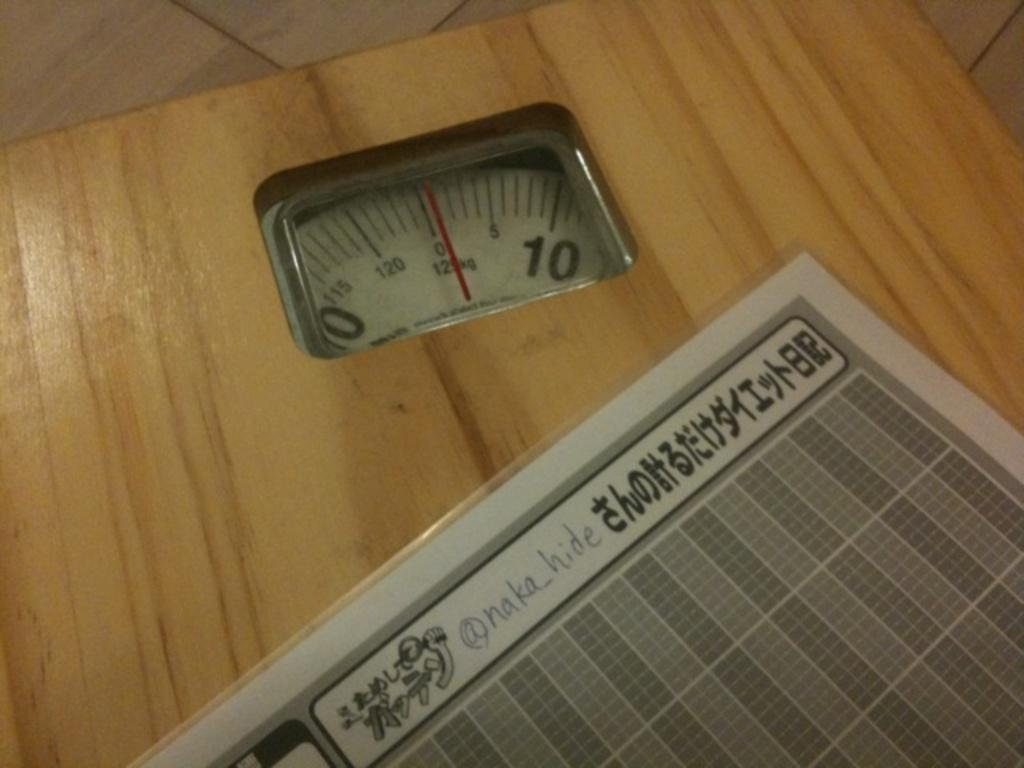What object is present in the image that is used for measuring weight? There is a weighing machine in the image that is used for measuring weight. Where is the weighing machine located in the image? The weighing machine is placed on the floor. What type of throne is depicted in the image? There is no throne present in the image; it features a weighing machine placed on the floor. How many apples are on the weighing machine in the image? There is no apple present on the weighing machine in the image. 